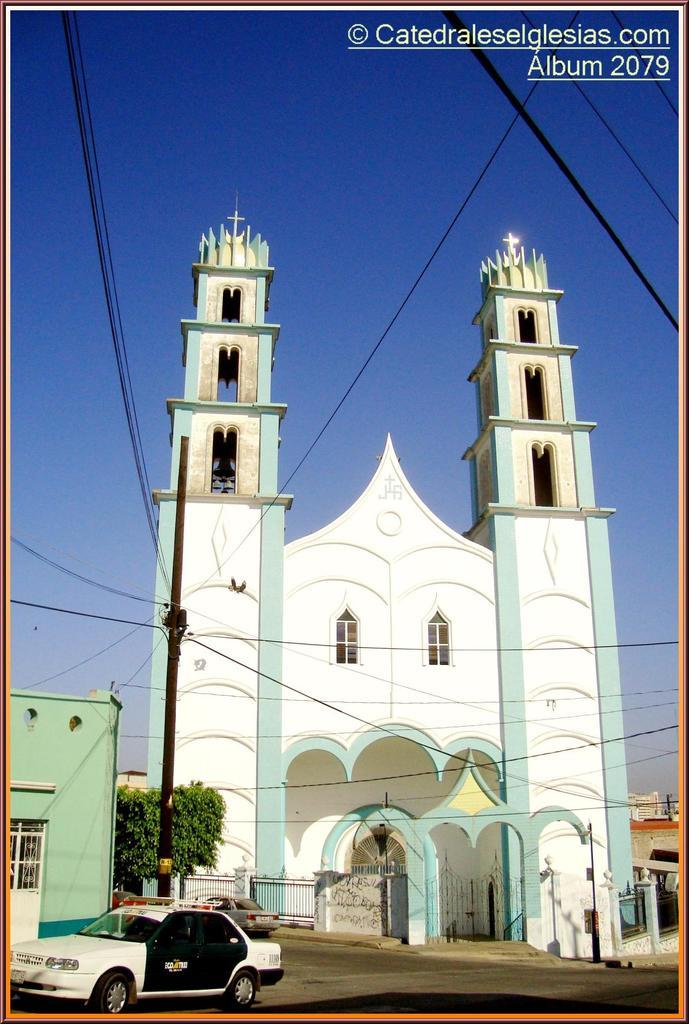<image>
Write a terse but informative summary of the picture. picture of a church with the text album overlaid right corner. 